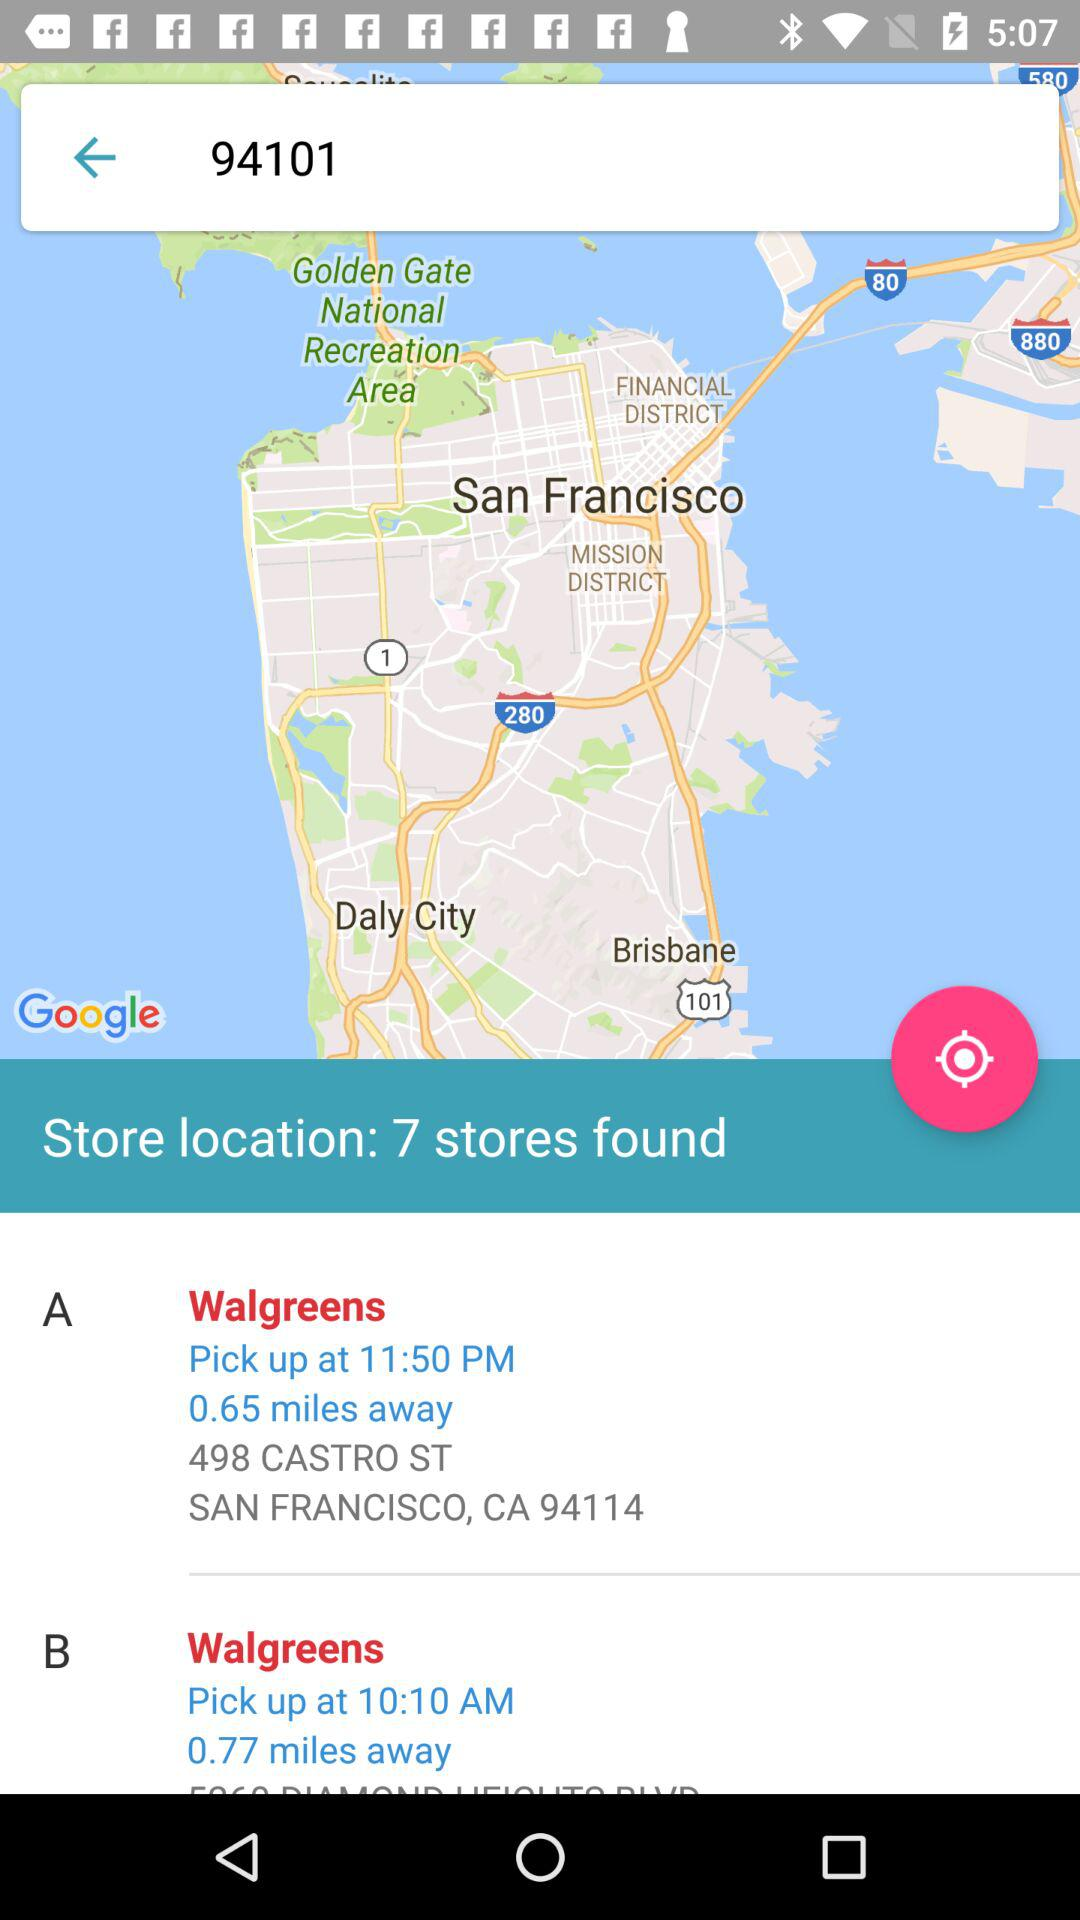How many stores are there?
Answer the question using a single word or phrase. 7 